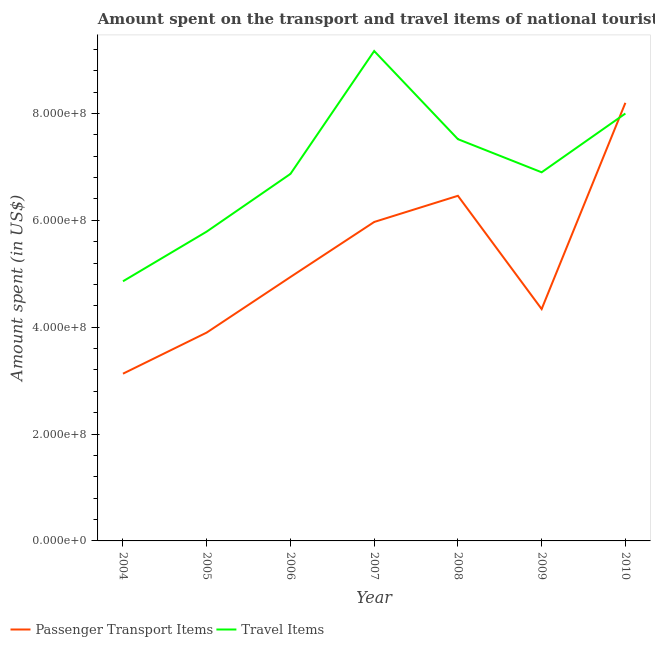What is the amount spent on passenger transport items in 2005?
Your response must be concise. 3.90e+08. Across all years, what is the maximum amount spent in travel items?
Give a very brief answer. 9.17e+08. Across all years, what is the minimum amount spent on passenger transport items?
Ensure brevity in your answer.  3.13e+08. In which year was the amount spent on passenger transport items maximum?
Ensure brevity in your answer.  2010. What is the total amount spent on passenger transport items in the graph?
Offer a terse response. 3.69e+09. What is the difference between the amount spent in travel items in 2006 and that in 2010?
Make the answer very short. -1.13e+08. What is the difference between the amount spent on passenger transport items in 2010 and the amount spent in travel items in 2009?
Your answer should be very brief. 1.30e+08. What is the average amount spent on passenger transport items per year?
Offer a very short reply. 5.28e+08. In the year 2010, what is the difference between the amount spent in travel items and amount spent on passenger transport items?
Provide a short and direct response. -2.00e+07. What is the ratio of the amount spent on passenger transport items in 2007 to that in 2009?
Provide a short and direct response. 1.38. Is the difference between the amount spent in travel items in 2006 and 2007 greater than the difference between the amount spent on passenger transport items in 2006 and 2007?
Make the answer very short. No. What is the difference between the highest and the second highest amount spent in travel items?
Offer a terse response. 1.17e+08. What is the difference between the highest and the lowest amount spent in travel items?
Provide a succinct answer. 4.31e+08. In how many years, is the amount spent on passenger transport items greater than the average amount spent on passenger transport items taken over all years?
Your response must be concise. 3. Is the sum of the amount spent in travel items in 2004 and 2010 greater than the maximum amount spent on passenger transport items across all years?
Your answer should be very brief. Yes. Does the amount spent on passenger transport items monotonically increase over the years?
Your response must be concise. No. Is the amount spent in travel items strictly less than the amount spent on passenger transport items over the years?
Your response must be concise. No. How many lines are there?
Provide a succinct answer. 2. How many years are there in the graph?
Give a very brief answer. 7. What is the difference between two consecutive major ticks on the Y-axis?
Provide a short and direct response. 2.00e+08. Does the graph contain grids?
Offer a terse response. No. Where does the legend appear in the graph?
Your answer should be compact. Bottom left. What is the title of the graph?
Offer a terse response. Amount spent on the transport and travel items of national tourists visited in Kenya. What is the label or title of the Y-axis?
Ensure brevity in your answer.  Amount spent (in US$). What is the Amount spent (in US$) in Passenger Transport Items in 2004?
Your response must be concise. 3.13e+08. What is the Amount spent (in US$) of Travel Items in 2004?
Offer a terse response. 4.86e+08. What is the Amount spent (in US$) of Passenger Transport Items in 2005?
Ensure brevity in your answer.  3.90e+08. What is the Amount spent (in US$) in Travel Items in 2005?
Keep it short and to the point. 5.79e+08. What is the Amount spent (in US$) of Passenger Transport Items in 2006?
Keep it short and to the point. 4.94e+08. What is the Amount spent (in US$) of Travel Items in 2006?
Your response must be concise. 6.87e+08. What is the Amount spent (in US$) of Passenger Transport Items in 2007?
Make the answer very short. 5.97e+08. What is the Amount spent (in US$) of Travel Items in 2007?
Ensure brevity in your answer.  9.17e+08. What is the Amount spent (in US$) of Passenger Transport Items in 2008?
Your response must be concise. 6.46e+08. What is the Amount spent (in US$) in Travel Items in 2008?
Offer a terse response. 7.52e+08. What is the Amount spent (in US$) in Passenger Transport Items in 2009?
Offer a very short reply. 4.34e+08. What is the Amount spent (in US$) of Travel Items in 2009?
Give a very brief answer. 6.90e+08. What is the Amount spent (in US$) in Passenger Transport Items in 2010?
Provide a succinct answer. 8.20e+08. What is the Amount spent (in US$) of Travel Items in 2010?
Your response must be concise. 8.00e+08. Across all years, what is the maximum Amount spent (in US$) in Passenger Transport Items?
Ensure brevity in your answer.  8.20e+08. Across all years, what is the maximum Amount spent (in US$) in Travel Items?
Keep it short and to the point. 9.17e+08. Across all years, what is the minimum Amount spent (in US$) in Passenger Transport Items?
Your answer should be compact. 3.13e+08. Across all years, what is the minimum Amount spent (in US$) in Travel Items?
Give a very brief answer. 4.86e+08. What is the total Amount spent (in US$) in Passenger Transport Items in the graph?
Your response must be concise. 3.69e+09. What is the total Amount spent (in US$) of Travel Items in the graph?
Offer a terse response. 4.91e+09. What is the difference between the Amount spent (in US$) of Passenger Transport Items in 2004 and that in 2005?
Offer a very short reply. -7.70e+07. What is the difference between the Amount spent (in US$) in Travel Items in 2004 and that in 2005?
Keep it short and to the point. -9.30e+07. What is the difference between the Amount spent (in US$) of Passenger Transport Items in 2004 and that in 2006?
Provide a succinct answer. -1.81e+08. What is the difference between the Amount spent (in US$) in Travel Items in 2004 and that in 2006?
Give a very brief answer. -2.01e+08. What is the difference between the Amount spent (in US$) in Passenger Transport Items in 2004 and that in 2007?
Your answer should be very brief. -2.84e+08. What is the difference between the Amount spent (in US$) in Travel Items in 2004 and that in 2007?
Ensure brevity in your answer.  -4.31e+08. What is the difference between the Amount spent (in US$) of Passenger Transport Items in 2004 and that in 2008?
Offer a terse response. -3.33e+08. What is the difference between the Amount spent (in US$) of Travel Items in 2004 and that in 2008?
Provide a short and direct response. -2.66e+08. What is the difference between the Amount spent (in US$) in Passenger Transport Items in 2004 and that in 2009?
Your answer should be compact. -1.21e+08. What is the difference between the Amount spent (in US$) of Travel Items in 2004 and that in 2009?
Make the answer very short. -2.04e+08. What is the difference between the Amount spent (in US$) of Passenger Transport Items in 2004 and that in 2010?
Keep it short and to the point. -5.07e+08. What is the difference between the Amount spent (in US$) in Travel Items in 2004 and that in 2010?
Your answer should be very brief. -3.14e+08. What is the difference between the Amount spent (in US$) of Passenger Transport Items in 2005 and that in 2006?
Offer a terse response. -1.04e+08. What is the difference between the Amount spent (in US$) in Travel Items in 2005 and that in 2006?
Your response must be concise. -1.08e+08. What is the difference between the Amount spent (in US$) in Passenger Transport Items in 2005 and that in 2007?
Make the answer very short. -2.07e+08. What is the difference between the Amount spent (in US$) in Travel Items in 2005 and that in 2007?
Provide a short and direct response. -3.38e+08. What is the difference between the Amount spent (in US$) in Passenger Transport Items in 2005 and that in 2008?
Your answer should be very brief. -2.56e+08. What is the difference between the Amount spent (in US$) of Travel Items in 2005 and that in 2008?
Give a very brief answer. -1.73e+08. What is the difference between the Amount spent (in US$) in Passenger Transport Items in 2005 and that in 2009?
Give a very brief answer. -4.40e+07. What is the difference between the Amount spent (in US$) in Travel Items in 2005 and that in 2009?
Keep it short and to the point. -1.11e+08. What is the difference between the Amount spent (in US$) of Passenger Transport Items in 2005 and that in 2010?
Give a very brief answer. -4.30e+08. What is the difference between the Amount spent (in US$) of Travel Items in 2005 and that in 2010?
Ensure brevity in your answer.  -2.21e+08. What is the difference between the Amount spent (in US$) of Passenger Transport Items in 2006 and that in 2007?
Your answer should be compact. -1.03e+08. What is the difference between the Amount spent (in US$) in Travel Items in 2006 and that in 2007?
Offer a very short reply. -2.30e+08. What is the difference between the Amount spent (in US$) of Passenger Transport Items in 2006 and that in 2008?
Offer a very short reply. -1.52e+08. What is the difference between the Amount spent (in US$) in Travel Items in 2006 and that in 2008?
Provide a short and direct response. -6.50e+07. What is the difference between the Amount spent (in US$) of Passenger Transport Items in 2006 and that in 2009?
Your answer should be very brief. 6.00e+07. What is the difference between the Amount spent (in US$) of Passenger Transport Items in 2006 and that in 2010?
Give a very brief answer. -3.26e+08. What is the difference between the Amount spent (in US$) in Travel Items in 2006 and that in 2010?
Give a very brief answer. -1.13e+08. What is the difference between the Amount spent (in US$) in Passenger Transport Items in 2007 and that in 2008?
Offer a very short reply. -4.90e+07. What is the difference between the Amount spent (in US$) of Travel Items in 2007 and that in 2008?
Keep it short and to the point. 1.65e+08. What is the difference between the Amount spent (in US$) in Passenger Transport Items in 2007 and that in 2009?
Your response must be concise. 1.63e+08. What is the difference between the Amount spent (in US$) in Travel Items in 2007 and that in 2009?
Your answer should be compact. 2.27e+08. What is the difference between the Amount spent (in US$) of Passenger Transport Items in 2007 and that in 2010?
Provide a short and direct response. -2.23e+08. What is the difference between the Amount spent (in US$) in Travel Items in 2007 and that in 2010?
Make the answer very short. 1.17e+08. What is the difference between the Amount spent (in US$) in Passenger Transport Items in 2008 and that in 2009?
Offer a very short reply. 2.12e+08. What is the difference between the Amount spent (in US$) of Travel Items in 2008 and that in 2009?
Provide a short and direct response. 6.20e+07. What is the difference between the Amount spent (in US$) of Passenger Transport Items in 2008 and that in 2010?
Ensure brevity in your answer.  -1.74e+08. What is the difference between the Amount spent (in US$) of Travel Items in 2008 and that in 2010?
Provide a succinct answer. -4.80e+07. What is the difference between the Amount spent (in US$) of Passenger Transport Items in 2009 and that in 2010?
Your answer should be very brief. -3.86e+08. What is the difference between the Amount spent (in US$) of Travel Items in 2009 and that in 2010?
Give a very brief answer. -1.10e+08. What is the difference between the Amount spent (in US$) of Passenger Transport Items in 2004 and the Amount spent (in US$) of Travel Items in 2005?
Ensure brevity in your answer.  -2.66e+08. What is the difference between the Amount spent (in US$) of Passenger Transport Items in 2004 and the Amount spent (in US$) of Travel Items in 2006?
Your answer should be compact. -3.74e+08. What is the difference between the Amount spent (in US$) of Passenger Transport Items in 2004 and the Amount spent (in US$) of Travel Items in 2007?
Offer a terse response. -6.04e+08. What is the difference between the Amount spent (in US$) in Passenger Transport Items in 2004 and the Amount spent (in US$) in Travel Items in 2008?
Offer a very short reply. -4.39e+08. What is the difference between the Amount spent (in US$) of Passenger Transport Items in 2004 and the Amount spent (in US$) of Travel Items in 2009?
Ensure brevity in your answer.  -3.77e+08. What is the difference between the Amount spent (in US$) of Passenger Transport Items in 2004 and the Amount spent (in US$) of Travel Items in 2010?
Your answer should be very brief. -4.87e+08. What is the difference between the Amount spent (in US$) in Passenger Transport Items in 2005 and the Amount spent (in US$) in Travel Items in 2006?
Make the answer very short. -2.97e+08. What is the difference between the Amount spent (in US$) in Passenger Transport Items in 2005 and the Amount spent (in US$) in Travel Items in 2007?
Give a very brief answer. -5.27e+08. What is the difference between the Amount spent (in US$) of Passenger Transport Items in 2005 and the Amount spent (in US$) of Travel Items in 2008?
Make the answer very short. -3.62e+08. What is the difference between the Amount spent (in US$) of Passenger Transport Items in 2005 and the Amount spent (in US$) of Travel Items in 2009?
Offer a very short reply. -3.00e+08. What is the difference between the Amount spent (in US$) in Passenger Transport Items in 2005 and the Amount spent (in US$) in Travel Items in 2010?
Make the answer very short. -4.10e+08. What is the difference between the Amount spent (in US$) in Passenger Transport Items in 2006 and the Amount spent (in US$) in Travel Items in 2007?
Offer a terse response. -4.23e+08. What is the difference between the Amount spent (in US$) of Passenger Transport Items in 2006 and the Amount spent (in US$) of Travel Items in 2008?
Your answer should be compact. -2.58e+08. What is the difference between the Amount spent (in US$) of Passenger Transport Items in 2006 and the Amount spent (in US$) of Travel Items in 2009?
Give a very brief answer. -1.96e+08. What is the difference between the Amount spent (in US$) in Passenger Transport Items in 2006 and the Amount spent (in US$) in Travel Items in 2010?
Your answer should be compact. -3.06e+08. What is the difference between the Amount spent (in US$) in Passenger Transport Items in 2007 and the Amount spent (in US$) in Travel Items in 2008?
Your answer should be compact. -1.55e+08. What is the difference between the Amount spent (in US$) of Passenger Transport Items in 2007 and the Amount spent (in US$) of Travel Items in 2009?
Ensure brevity in your answer.  -9.30e+07. What is the difference between the Amount spent (in US$) of Passenger Transport Items in 2007 and the Amount spent (in US$) of Travel Items in 2010?
Provide a short and direct response. -2.03e+08. What is the difference between the Amount spent (in US$) in Passenger Transport Items in 2008 and the Amount spent (in US$) in Travel Items in 2009?
Offer a terse response. -4.40e+07. What is the difference between the Amount spent (in US$) of Passenger Transport Items in 2008 and the Amount spent (in US$) of Travel Items in 2010?
Provide a short and direct response. -1.54e+08. What is the difference between the Amount spent (in US$) in Passenger Transport Items in 2009 and the Amount spent (in US$) in Travel Items in 2010?
Provide a succinct answer. -3.66e+08. What is the average Amount spent (in US$) in Passenger Transport Items per year?
Provide a succinct answer. 5.28e+08. What is the average Amount spent (in US$) in Travel Items per year?
Offer a very short reply. 7.02e+08. In the year 2004, what is the difference between the Amount spent (in US$) of Passenger Transport Items and Amount spent (in US$) of Travel Items?
Provide a short and direct response. -1.73e+08. In the year 2005, what is the difference between the Amount spent (in US$) of Passenger Transport Items and Amount spent (in US$) of Travel Items?
Your answer should be very brief. -1.89e+08. In the year 2006, what is the difference between the Amount spent (in US$) in Passenger Transport Items and Amount spent (in US$) in Travel Items?
Provide a succinct answer. -1.93e+08. In the year 2007, what is the difference between the Amount spent (in US$) of Passenger Transport Items and Amount spent (in US$) of Travel Items?
Provide a short and direct response. -3.20e+08. In the year 2008, what is the difference between the Amount spent (in US$) in Passenger Transport Items and Amount spent (in US$) in Travel Items?
Your response must be concise. -1.06e+08. In the year 2009, what is the difference between the Amount spent (in US$) in Passenger Transport Items and Amount spent (in US$) in Travel Items?
Make the answer very short. -2.56e+08. What is the ratio of the Amount spent (in US$) of Passenger Transport Items in 2004 to that in 2005?
Give a very brief answer. 0.8. What is the ratio of the Amount spent (in US$) of Travel Items in 2004 to that in 2005?
Your answer should be compact. 0.84. What is the ratio of the Amount spent (in US$) of Passenger Transport Items in 2004 to that in 2006?
Your answer should be very brief. 0.63. What is the ratio of the Amount spent (in US$) of Travel Items in 2004 to that in 2006?
Ensure brevity in your answer.  0.71. What is the ratio of the Amount spent (in US$) of Passenger Transport Items in 2004 to that in 2007?
Make the answer very short. 0.52. What is the ratio of the Amount spent (in US$) of Travel Items in 2004 to that in 2007?
Provide a succinct answer. 0.53. What is the ratio of the Amount spent (in US$) of Passenger Transport Items in 2004 to that in 2008?
Make the answer very short. 0.48. What is the ratio of the Amount spent (in US$) of Travel Items in 2004 to that in 2008?
Keep it short and to the point. 0.65. What is the ratio of the Amount spent (in US$) in Passenger Transport Items in 2004 to that in 2009?
Your answer should be compact. 0.72. What is the ratio of the Amount spent (in US$) of Travel Items in 2004 to that in 2009?
Offer a terse response. 0.7. What is the ratio of the Amount spent (in US$) of Passenger Transport Items in 2004 to that in 2010?
Your response must be concise. 0.38. What is the ratio of the Amount spent (in US$) of Travel Items in 2004 to that in 2010?
Your response must be concise. 0.61. What is the ratio of the Amount spent (in US$) of Passenger Transport Items in 2005 to that in 2006?
Your response must be concise. 0.79. What is the ratio of the Amount spent (in US$) in Travel Items in 2005 to that in 2006?
Provide a succinct answer. 0.84. What is the ratio of the Amount spent (in US$) of Passenger Transport Items in 2005 to that in 2007?
Your answer should be very brief. 0.65. What is the ratio of the Amount spent (in US$) in Travel Items in 2005 to that in 2007?
Your answer should be compact. 0.63. What is the ratio of the Amount spent (in US$) of Passenger Transport Items in 2005 to that in 2008?
Provide a succinct answer. 0.6. What is the ratio of the Amount spent (in US$) of Travel Items in 2005 to that in 2008?
Your answer should be very brief. 0.77. What is the ratio of the Amount spent (in US$) of Passenger Transport Items in 2005 to that in 2009?
Offer a terse response. 0.9. What is the ratio of the Amount spent (in US$) of Travel Items in 2005 to that in 2009?
Keep it short and to the point. 0.84. What is the ratio of the Amount spent (in US$) in Passenger Transport Items in 2005 to that in 2010?
Give a very brief answer. 0.48. What is the ratio of the Amount spent (in US$) in Travel Items in 2005 to that in 2010?
Your answer should be very brief. 0.72. What is the ratio of the Amount spent (in US$) of Passenger Transport Items in 2006 to that in 2007?
Your answer should be very brief. 0.83. What is the ratio of the Amount spent (in US$) of Travel Items in 2006 to that in 2007?
Offer a terse response. 0.75. What is the ratio of the Amount spent (in US$) in Passenger Transport Items in 2006 to that in 2008?
Your response must be concise. 0.76. What is the ratio of the Amount spent (in US$) in Travel Items in 2006 to that in 2008?
Your answer should be very brief. 0.91. What is the ratio of the Amount spent (in US$) in Passenger Transport Items in 2006 to that in 2009?
Your answer should be compact. 1.14. What is the ratio of the Amount spent (in US$) of Passenger Transport Items in 2006 to that in 2010?
Offer a terse response. 0.6. What is the ratio of the Amount spent (in US$) of Travel Items in 2006 to that in 2010?
Make the answer very short. 0.86. What is the ratio of the Amount spent (in US$) in Passenger Transport Items in 2007 to that in 2008?
Your answer should be compact. 0.92. What is the ratio of the Amount spent (in US$) in Travel Items in 2007 to that in 2008?
Ensure brevity in your answer.  1.22. What is the ratio of the Amount spent (in US$) of Passenger Transport Items in 2007 to that in 2009?
Your answer should be very brief. 1.38. What is the ratio of the Amount spent (in US$) of Travel Items in 2007 to that in 2009?
Your response must be concise. 1.33. What is the ratio of the Amount spent (in US$) of Passenger Transport Items in 2007 to that in 2010?
Offer a very short reply. 0.73. What is the ratio of the Amount spent (in US$) of Travel Items in 2007 to that in 2010?
Offer a very short reply. 1.15. What is the ratio of the Amount spent (in US$) in Passenger Transport Items in 2008 to that in 2009?
Your response must be concise. 1.49. What is the ratio of the Amount spent (in US$) in Travel Items in 2008 to that in 2009?
Keep it short and to the point. 1.09. What is the ratio of the Amount spent (in US$) of Passenger Transport Items in 2008 to that in 2010?
Offer a terse response. 0.79. What is the ratio of the Amount spent (in US$) in Passenger Transport Items in 2009 to that in 2010?
Your answer should be compact. 0.53. What is the ratio of the Amount spent (in US$) in Travel Items in 2009 to that in 2010?
Keep it short and to the point. 0.86. What is the difference between the highest and the second highest Amount spent (in US$) in Passenger Transport Items?
Provide a succinct answer. 1.74e+08. What is the difference between the highest and the second highest Amount spent (in US$) in Travel Items?
Your answer should be compact. 1.17e+08. What is the difference between the highest and the lowest Amount spent (in US$) of Passenger Transport Items?
Offer a very short reply. 5.07e+08. What is the difference between the highest and the lowest Amount spent (in US$) of Travel Items?
Your answer should be very brief. 4.31e+08. 